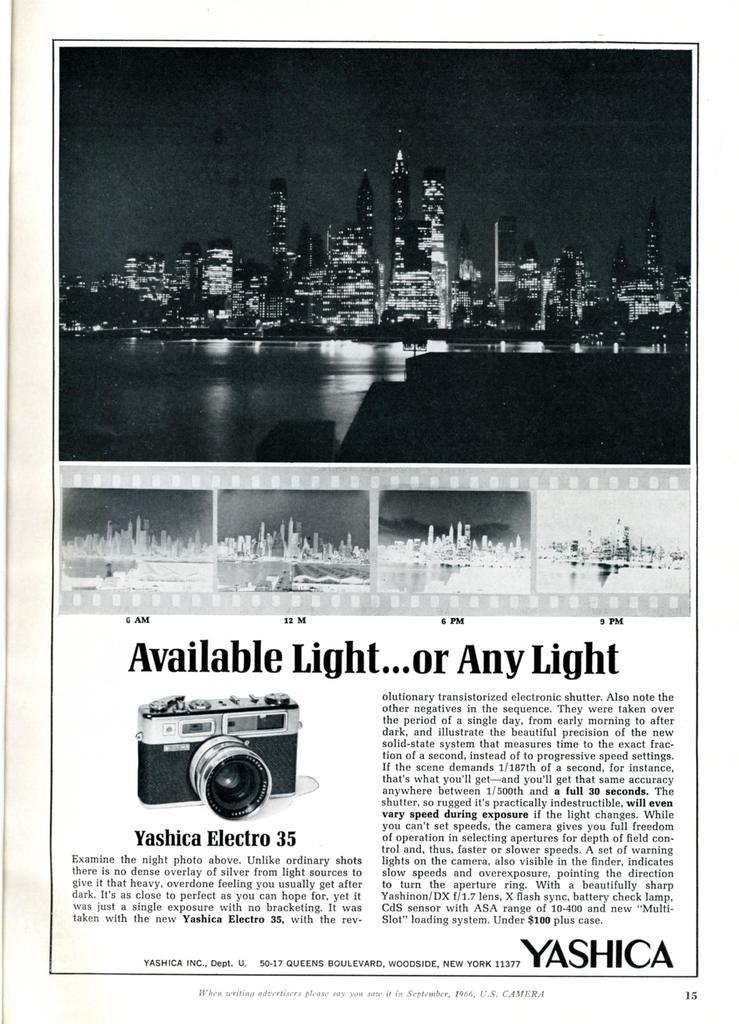<image>
Write a terse but informative summary of the picture. A black and white advertisement for a Yashica Electro 35 camera. 